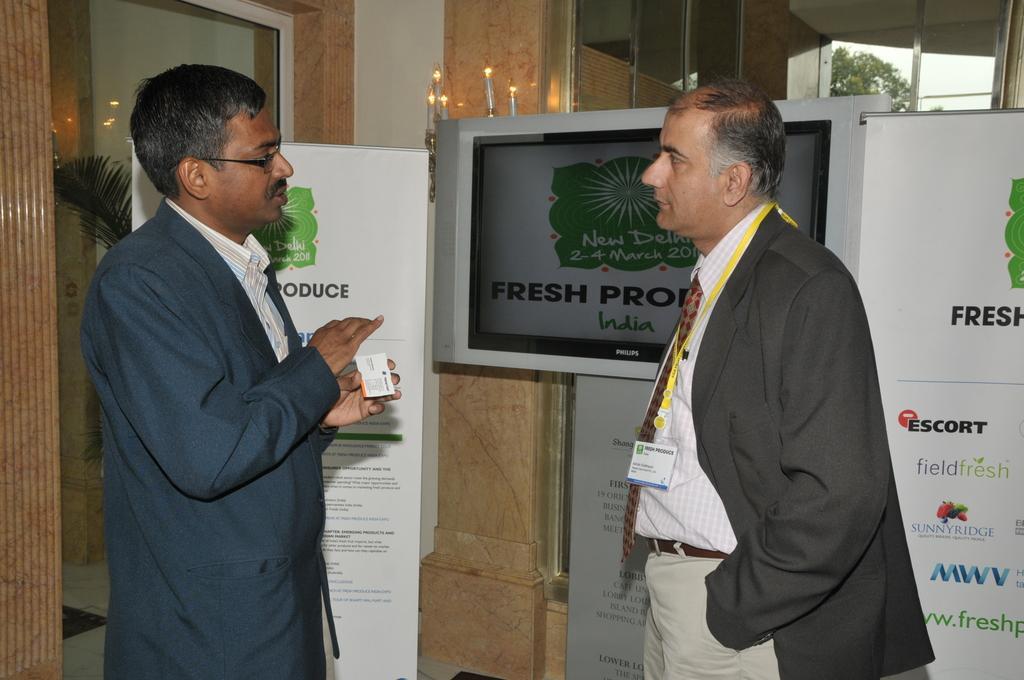Could you give a brief overview of what you see in this image? In this image I can see two persons standing and one of the person is holding a card. There are boards, glass walls, there is a monitor, a plant , tree and also there is sky. 